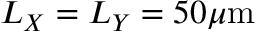<formula> <loc_0><loc_0><loc_500><loc_500>L _ { X } = L _ { Y } = 5 0 \mu m</formula> 